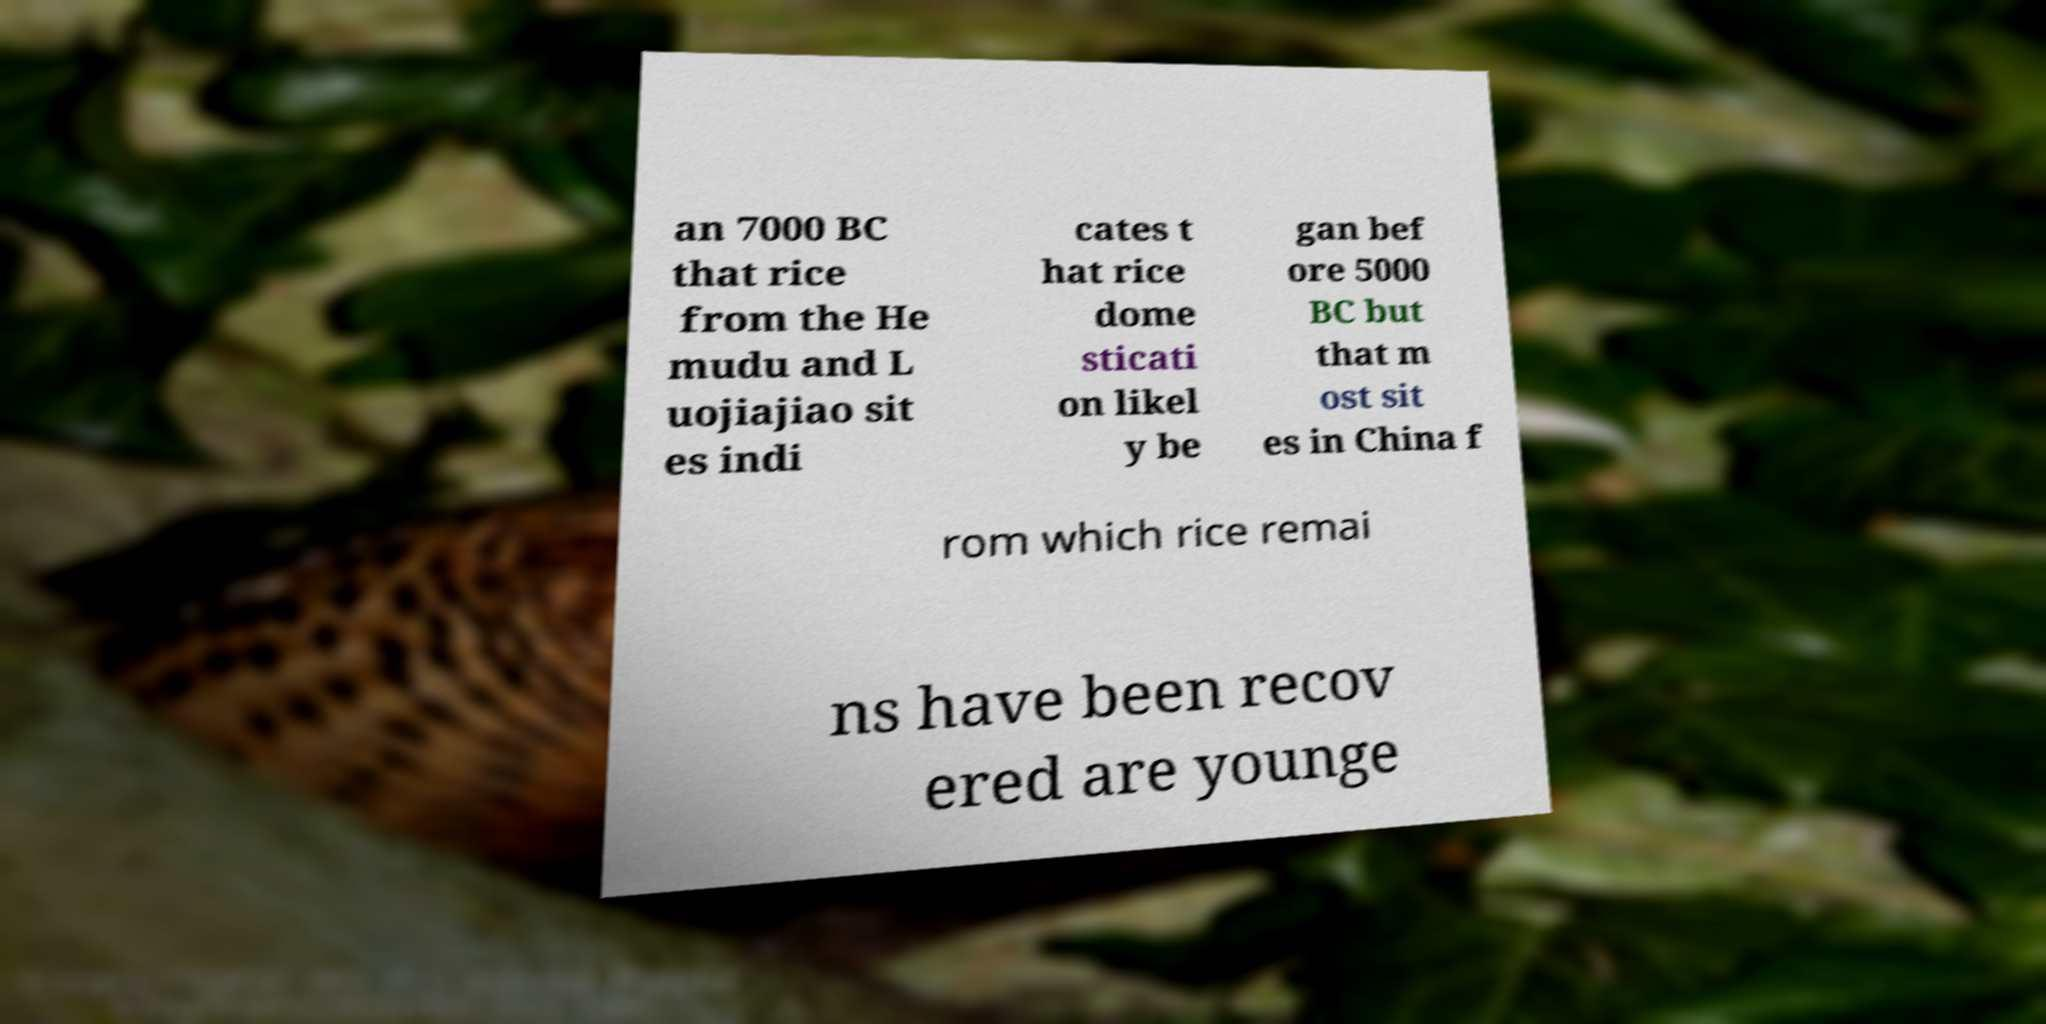What messages or text are displayed in this image? I need them in a readable, typed format. an 7000 BC that rice from the He mudu and L uojiajiao sit es indi cates t hat rice dome sticati on likel y be gan bef ore 5000 BC but that m ost sit es in China f rom which rice remai ns have been recov ered are younge 